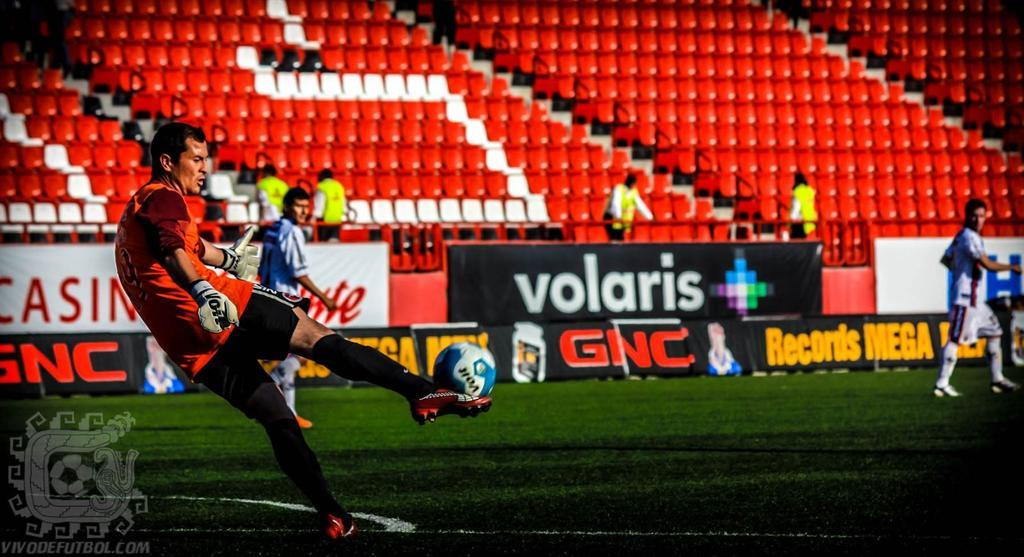<image>
Summarize the visual content of the image. the ad for volaris is on the side of a field 